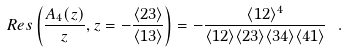<formula> <loc_0><loc_0><loc_500><loc_500>R e s \left ( \frac { A _ { 4 } ( z ) } { z } , z = - \frac { \langle 2 3 \rangle } { \langle 1 3 \rangle } \right ) = - \frac { \langle 1 2 \rangle ^ { 4 } } { \langle 1 2 \rangle \langle 2 3 \rangle \langle 3 4 \rangle \langle 4 1 \rangle } \ .</formula> 